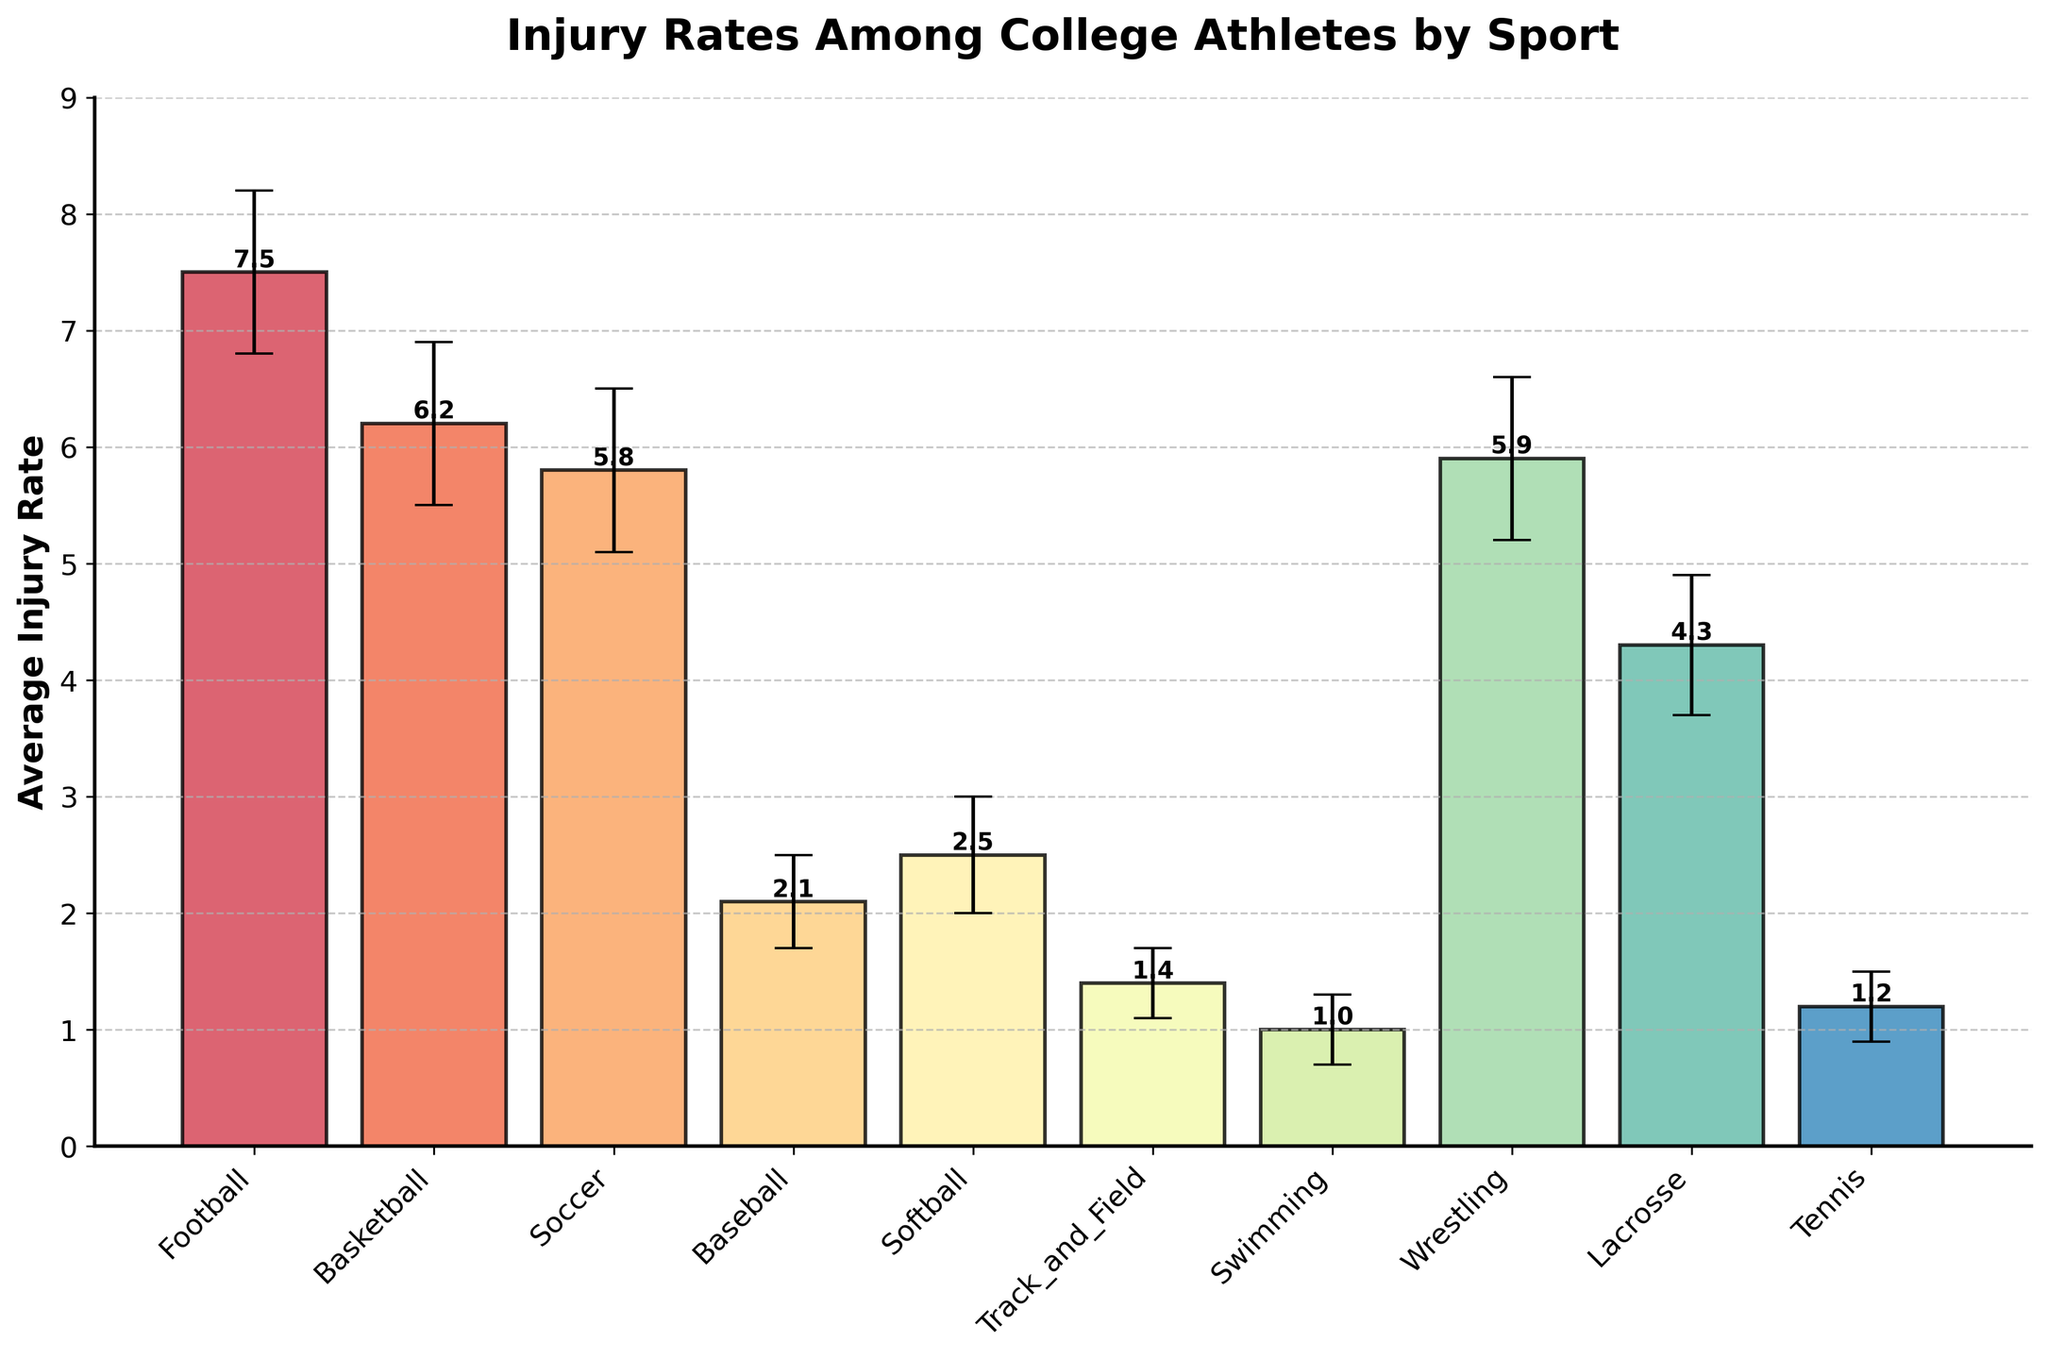What's the title of the chart? The title is displayed at the top of the chart in bold text.
Answer: Injury Rates Among College Athletes by Sport What sport has the highest average injury rate? By looking at the height of the bars, Football has the highest average injury rate.
Answer: Football Which sport has the lowest average injury rate? The lowest bar corresponds to Swimming.
Answer: Swimming What are the y-axis label and its measurement unit? The y-axis label is shown vertically along the y-axis.
Answer: Average Injury Rate What is the average injury rate for Soccer? Locate the bar corresponding to Soccer and check the text above the bar, which shows the exact value.
Answer: 5.8 How do the injury rates for Soccer and Wrestling compare? Compare the height of the Soccer and Wrestling bars and read their exact values. Soccer has an injury rate of 5.8, while Wrestling has an injury rate of 5.9, so Wrestling has a slightly higher average injury rate.
Answer: Wrestling Which sports have a higher average injury rate than Basketball? Compare other bars' heights to Basketball's bar, which has an average injury rate of 6.2. The bars higher than Basketball’s are Football and Wrestling.
Answer: Football, Wrestling What is the error range for the Lacrosse injury rate? The error ranges are depicted as bars extending above and below the top of each bar; for Lacrosse, it extends between 3.7 and 4.9.
Answer: 3.7 to 4.9 What's the difference in the average injury rates between Football and Baseball? Football has an injury rate of 7.5 and Baseball has 2.1. Subtract the Baseball rate from the Football rate. 7.5 - 2.1 = 5.4.
Answer: 5.4 What's the range of confidence intervals for Tennis? For Tennis, check the bar and the error lines extending above and below it, ranging from 0.9 to 1.5.
Answer: 0.9 to 1.5 